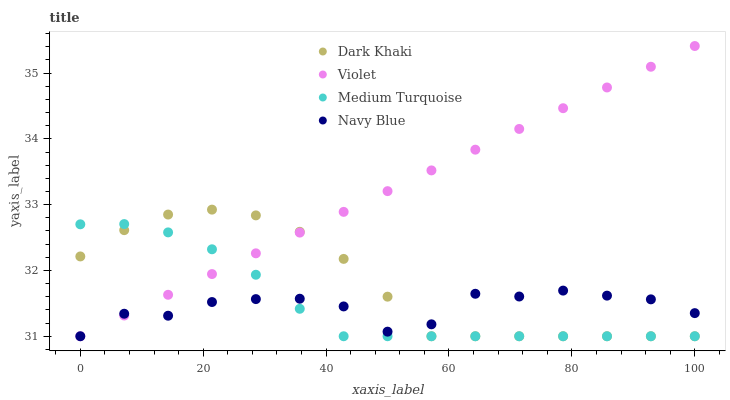Does Navy Blue have the minimum area under the curve?
Answer yes or no. Yes. Does Violet have the maximum area under the curve?
Answer yes or no. Yes. Does Medium Turquoise have the minimum area under the curve?
Answer yes or no. No. Does Medium Turquoise have the maximum area under the curve?
Answer yes or no. No. Is Violet the smoothest?
Answer yes or no. Yes. Is Navy Blue the roughest?
Answer yes or no. Yes. Is Medium Turquoise the smoothest?
Answer yes or no. No. Is Medium Turquoise the roughest?
Answer yes or no. No. Does Dark Khaki have the lowest value?
Answer yes or no. Yes. Does Violet have the highest value?
Answer yes or no. Yes. Does Medium Turquoise have the highest value?
Answer yes or no. No. Does Dark Khaki intersect Navy Blue?
Answer yes or no. Yes. Is Dark Khaki less than Navy Blue?
Answer yes or no. No. Is Dark Khaki greater than Navy Blue?
Answer yes or no. No. 